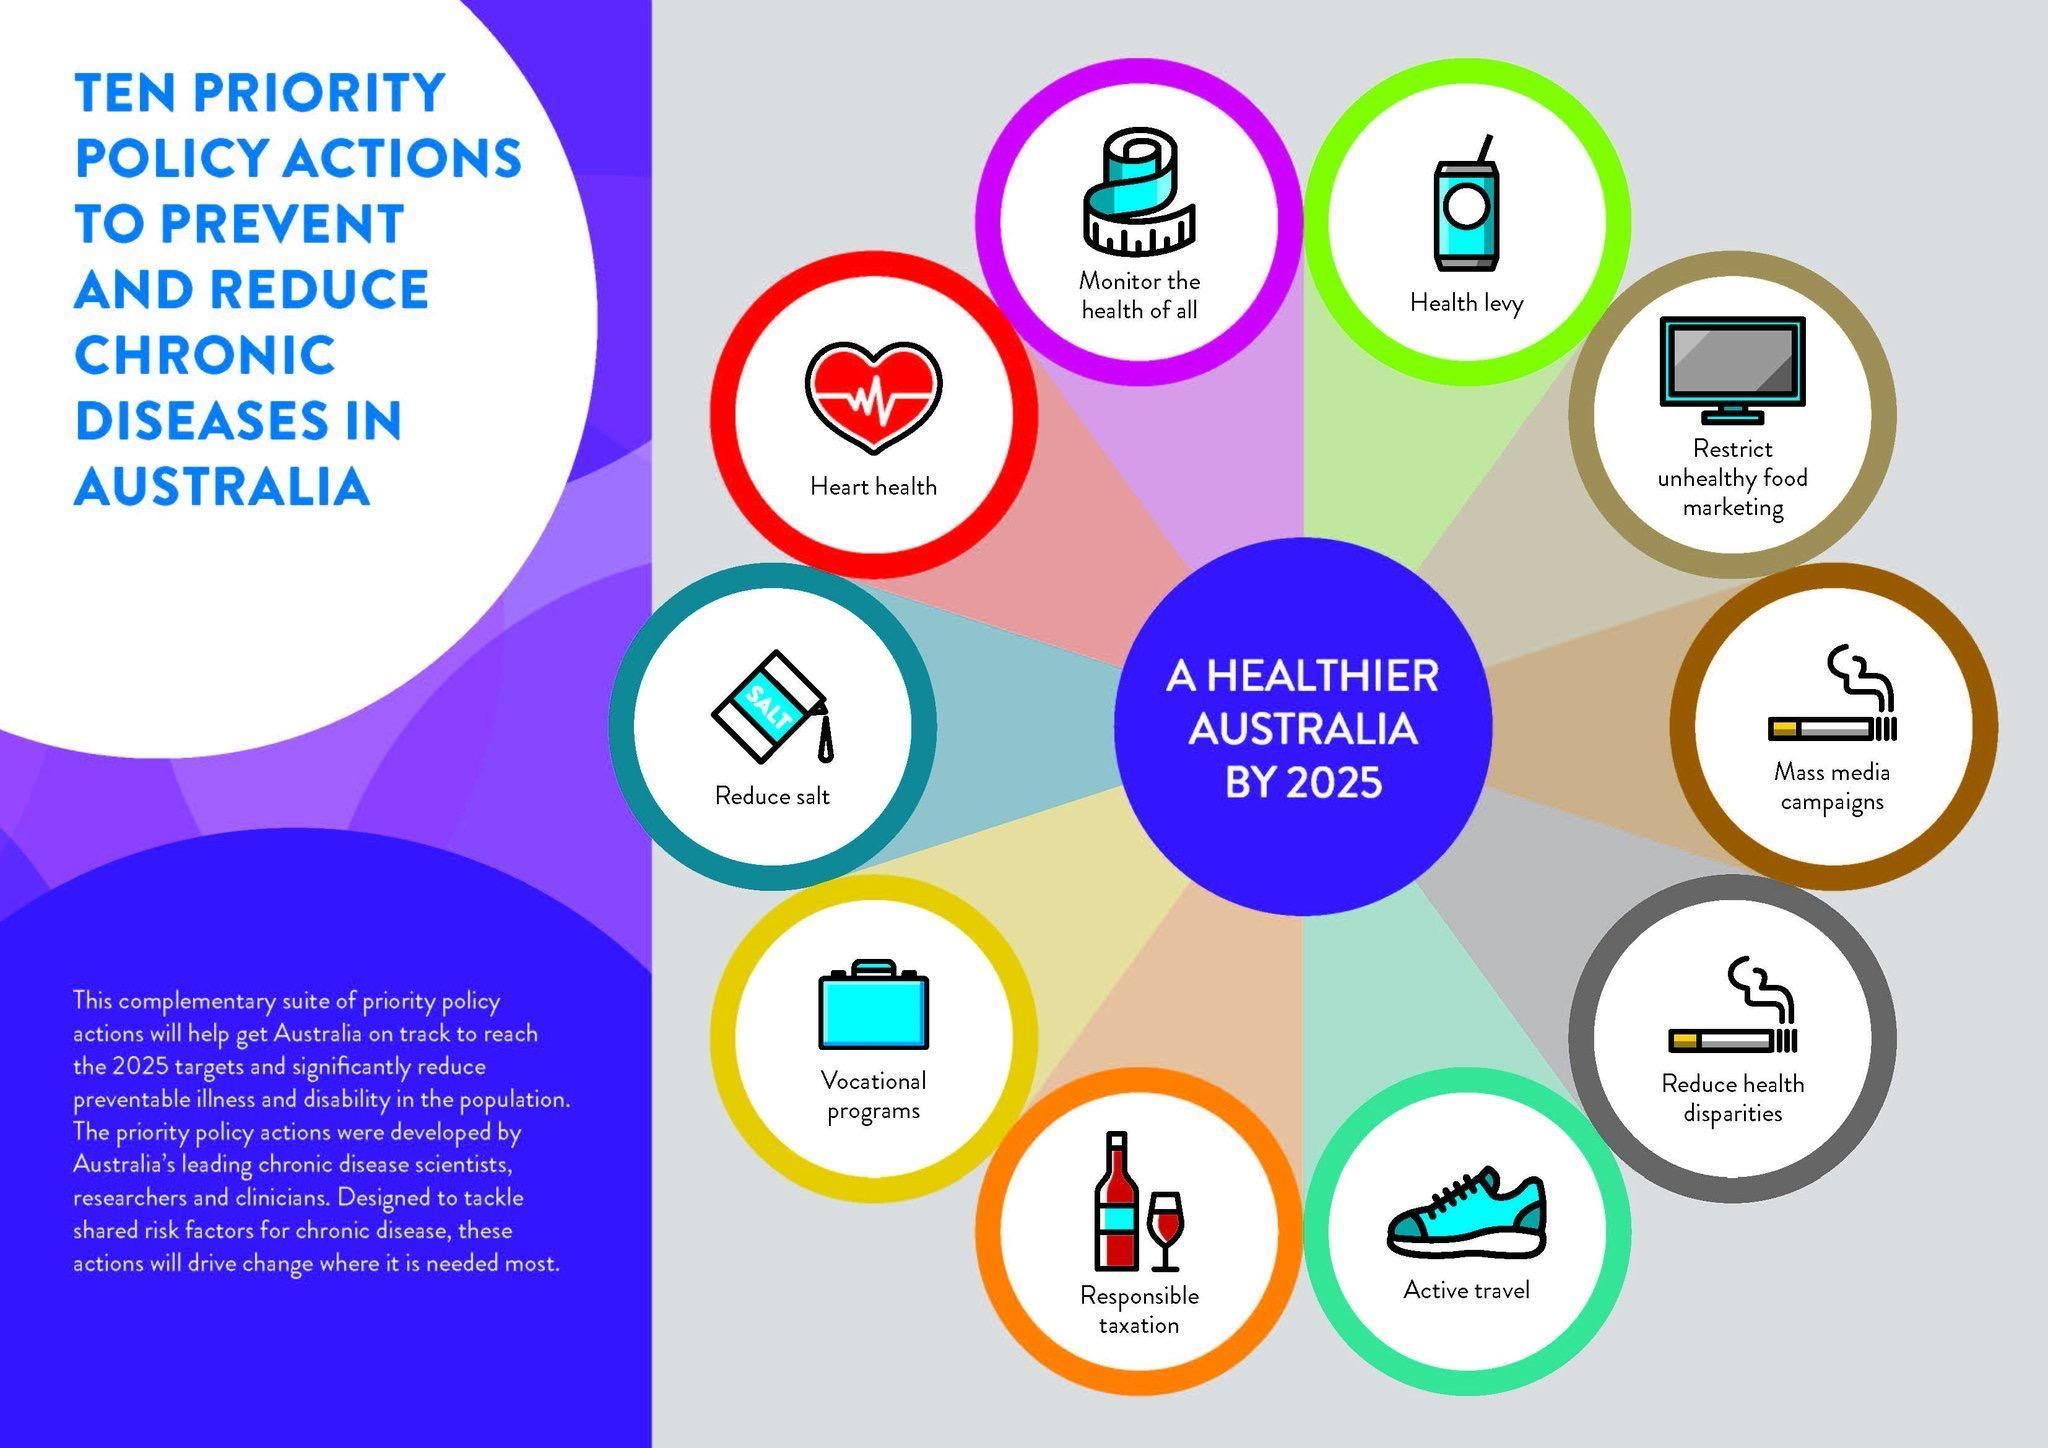What needs to be undertaken to reduce smoking, mass media campaigns, active travel, or vocational programs ?
Answer the question with a short phrase. mass media campaigns What is the color of the policy action heart health, orange, red, or yellow? red Which policy actions have an image of a cigarette ? Mass media campaigns, Reduce health disparities 